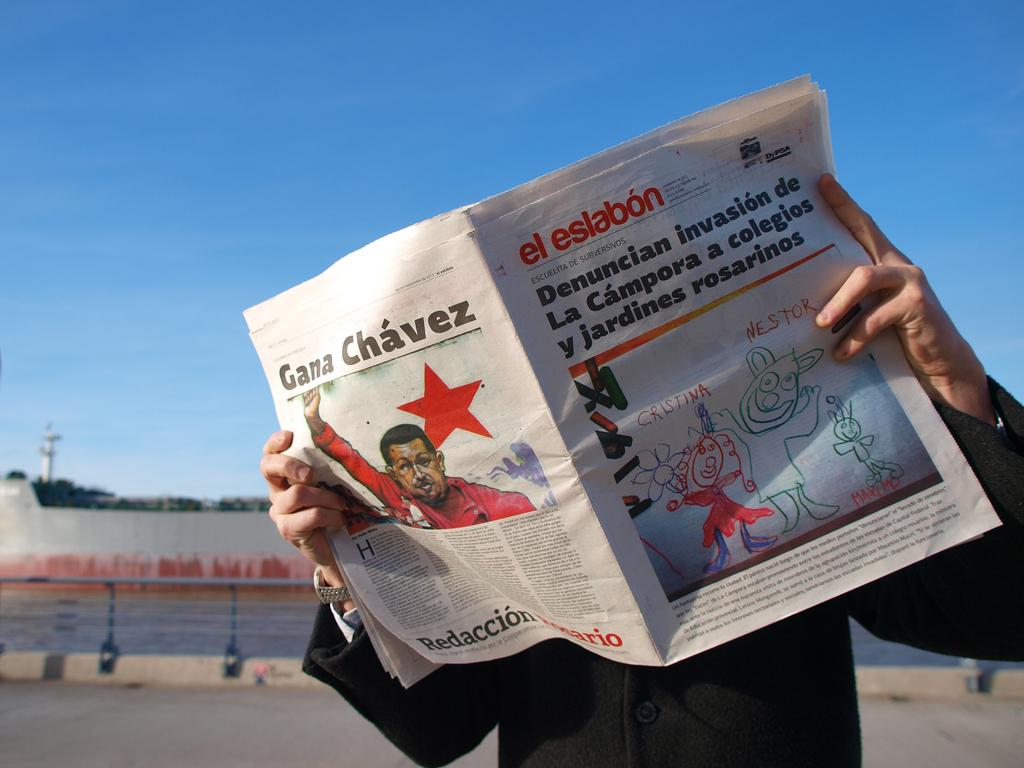What is the person in the image holding? The person is holding a newspaper. What can be found in the newspaper? The newspaper contains pictures and letters. What structures are present in the image? There is a pole, a wall, and a tree in the image. What type of orange is the person eating in the image? There is no orange present in the image; the person is holding a newspaper. 